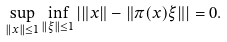<formula> <loc_0><loc_0><loc_500><loc_500>\sup _ { \| x \| \leq 1 } \inf _ { \| \xi \| \leq 1 } | \| x \| - \| \pi ( x ) \xi \| | = 0 .</formula> 